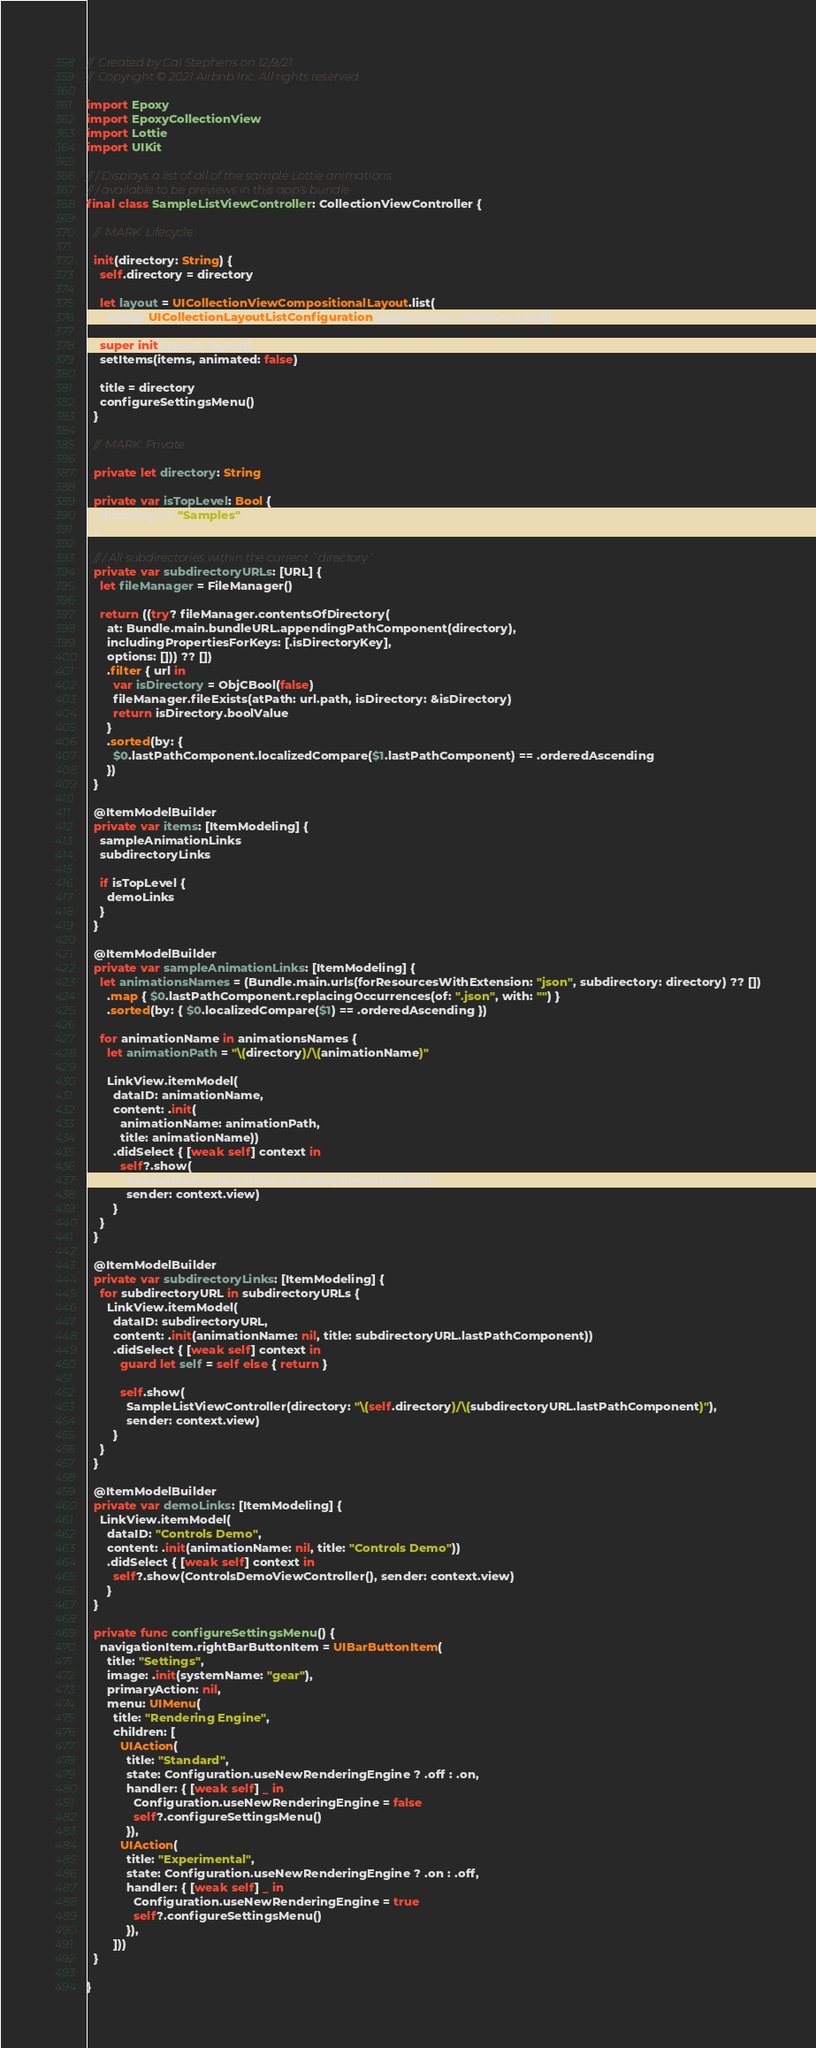Convert code to text. <code><loc_0><loc_0><loc_500><loc_500><_Swift_>// Created by Cal Stephens on 12/9/21.
// Copyright © 2021 Airbnb Inc. All rights reserved.

import Epoxy
import EpoxyCollectionView
import Lottie
import UIKit

/// Displays a list of all of the sample Lottie animations
/// available to be previews in this app's bundle
final class SampleListViewController: CollectionViewController {

  // MARK: Lifecycle

  init(directory: String) {
    self.directory = directory

    let layout = UICollectionViewCompositionalLayout.list(
      using: UICollectionLayoutListConfiguration(appearance: .insetGrouped))

    super.init(layout: layout)
    setItems(items, animated: false)

    title = directory
    configureSettingsMenu()
  }

  // MARK: Private

  private let directory: String

  private var isTopLevel: Bool {
    directory == "Samples"
  }

  /// All subdirectories within the current `directory`
  private var subdirectoryURLs: [URL] {
    let fileManager = FileManager()

    return ((try? fileManager.contentsOfDirectory(
      at: Bundle.main.bundleURL.appendingPathComponent(directory),
      includingPropertiesForKeys: [.isDirectoryKey],
      options: [])) ?? [])
      .filter { url in
        var isDirectory = ObjCBool(false)
        fileManager.fileExists(atPath: url.path, isDirectory: &isDirectory)
        return isDirectory.boolValue
      }
      .sorted(by: {
        $0.lastPathComponent.localizedCompare($1.lastPathComponent) == .orderedAscending
      })
  }

  @ItemModelBuilder
  private var items: [ItemModeling] {
    sampleAnimationLinks
    subdirectoryLinks

    if isTopLevel {
      demoLinks
    }
  }

  @ItemModelBuilder
  private var sampleAnimationLinks: [ItemModeling] {
    let animationsNames = (Bundle.main.urls(forResourcesWithExtension: "json", subdirectory: directory) ?? [])
      .map { $0.lastPathComponent.replacingOccurrences(of: ".json", with: "") }
      .sorted(by: { $0.localizedCompare($1) == .orderedAscending })

    for animationName in animationsNames {
      let animationPath = "\(directory)/\(animationName)"

      LinkView.itemModel(
        dataID: animationName,
        content: .init(
          animationName: animationPath,
          title: animationName))
        .didSelect { [weak self] context in
          self?.show(
            AnimationPreviewViewController(animationPath),
            sender: context.view)
        }
    }
  }

  @ItemModelBuilder
  private var subdirectoryLinks: [ItemModeling] {
    for subdirectoryURL in subdirectoryURLs {
      LinkView.itemModel(
        dataID: subdirectoryURL,
        content: .init(animationName: nil, title: subdirectoryURL.lastPathComponent))
        .didSelect { [weak self] context in
          guard let self = self else { return }

          self.show(
            SampleListViewController(directory: "\(self.directory)/\(subdirectoryURL.lastPathComponent)"),
            sender: context.view)
        }
    }
  }

  @ItemModelBuilder
  private var demoLinks: [ItemModeling] {
    LinkView.itemModel(
      dataID: "Controls Demo",
      content: .init(animationName: nil, title: "Controls Demo"))
      .didSelect { [weak self] context in
        self?.show(ControlsDemoViewController(), sender: context.view)
      }
  }

  private func configureSettingsMenu() {
    navigationItem.rightBarButtonItem = UIBarButtonItem(
      title: "Settings",
      image: .init(systemName: "gear"),
      primaryAction: nil,
      menu: UIMenu(
        title: "Rendering Engine",
        children: [
          UIAction(
            title: "Standard",
            state: Configuration.useNewRenderingEngine ? .off : .on,
            handler: { [weak self] _ in
              Configuration.useNewRenderingEngine = false
              self?.configureSettingsMenu()
            }),
          UIAction(
            title: "Experimental",
            state: Configuration.useNewRenderingEngine ? .on : .off,
            handler: { [weak self] _ in
              Configuration.useNewRenderingEngine = true
              self?.configureSettingsMenu()
            }),
        ]))
  }

}
</code> 